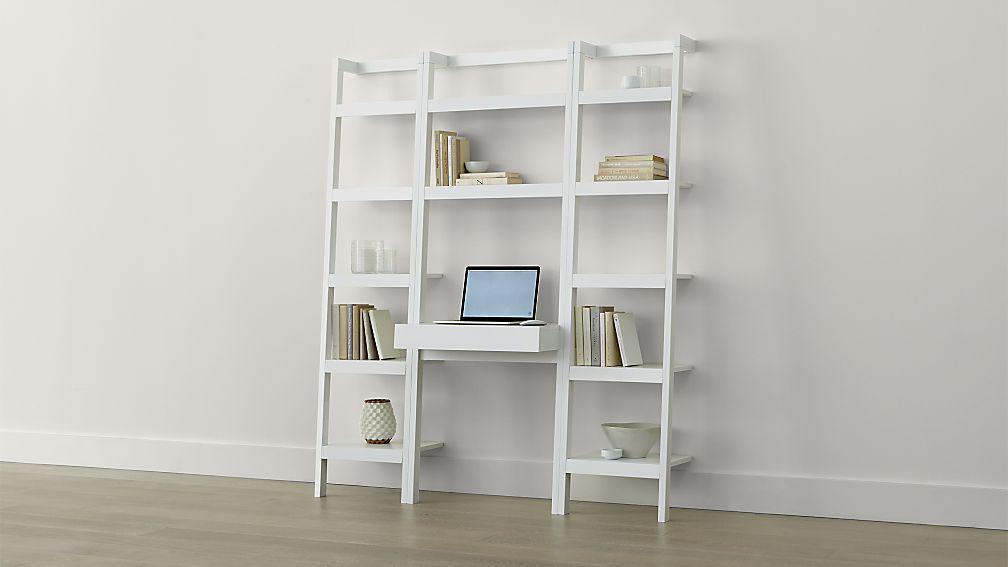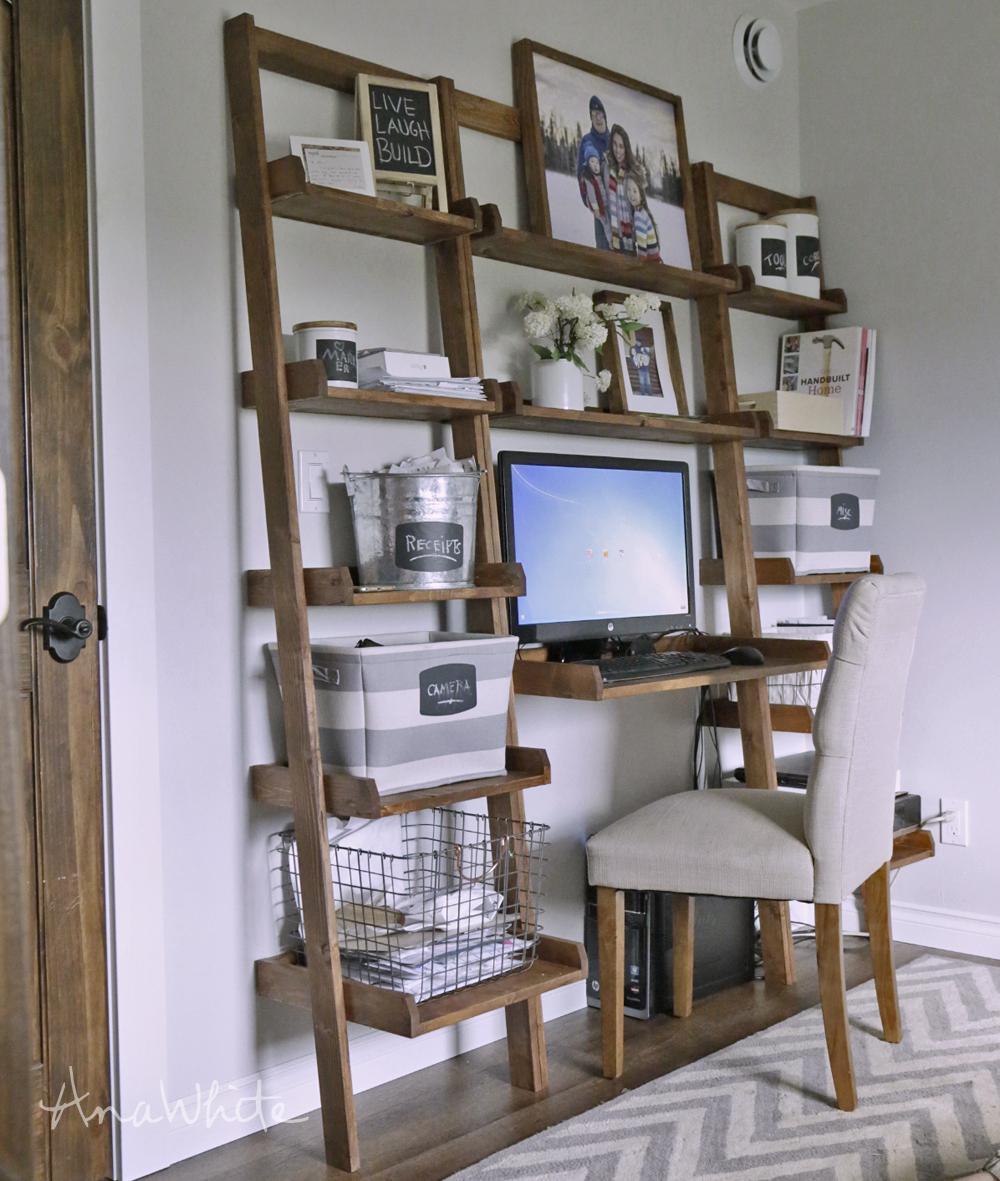The first image is the image on the left, the second image is the image on the right. For the images shown, is this caption "there is a herringbone striped rug in front of a wall desk with a white chair with wooden legs" true? Answer yes or no. Yes. 